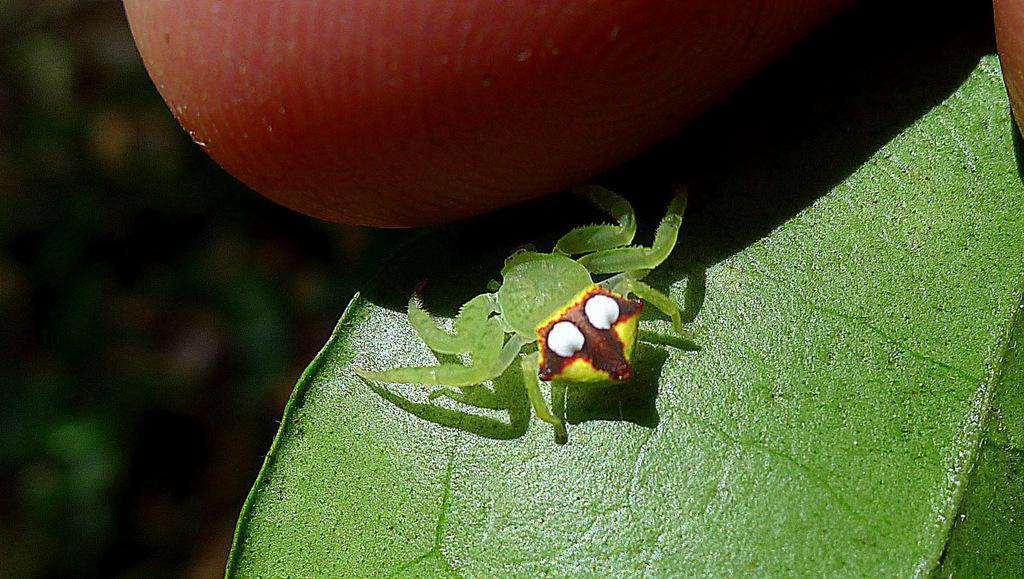What is present on the green leaf in the image? There is an insect on a green leaf in the image. What can be seen at the top of the image? There is an object at the top of the image. How would you describe the background of the image? The background of the image is blurry. What type of skin condition can be seen on the insect in the image? There is no indication of a skin condition on the insect in the image, as insects do not have skin like humans. 